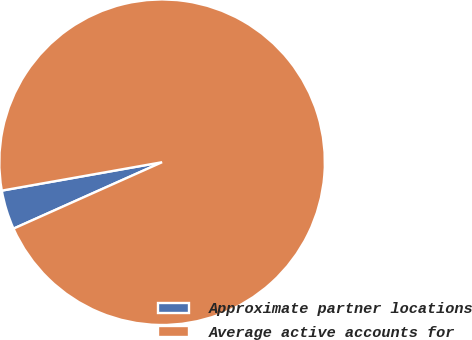Convert chart to OTSL. <chart><loc_0><loc_0><loc_500><loc_500><pie_chart><fcel>Approximate partner locations<fcel>Average active accounts for<nl><fcel>3.9%<fcel>96.1%<nl></chart> 